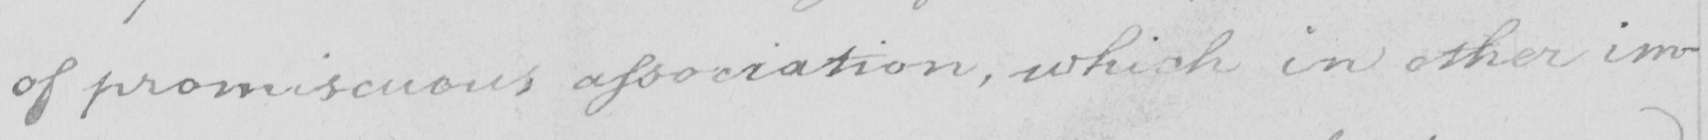Can you tell me what this handwritten text says? of promiscuous association , which in other im- 